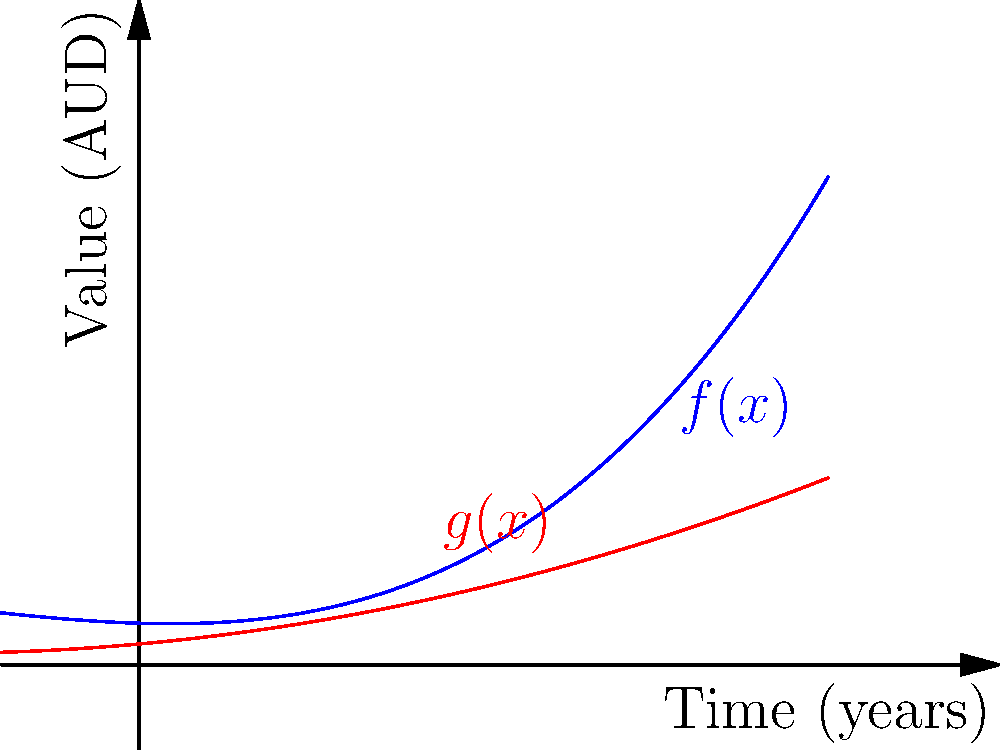As a rare film collector, you're tracking the value of two vintage movie posters over time. The blue curve represents the value of a classic Australian film poster ($f(x)$), while the red curve represents an international blockbuster poster ($g(x)$). Both functions are polynomials, where $x$ represents the number of years from now. At which point in the future will the value of the Australian film poster start growing faster than the international blockbuster poster? To determine when the Australian film poster's value ($f(x)$) starts growing faster than the international blockbuster poster's value ($g(x)$), we need to compare their rates of change. This is done by comparing their derivatives.

1) First, let's find the derivatives of both functions:
   $f(x) = 0.5x^3 + 2x^2 - x + 10$
   $f'(x) = 1.5x^2 + 4x - 1$

   $g(x) = x^2 + 3x + 5$
   $g'(x) = 2x + 3$

2) The Australian poster's value is growing faster when $f'(x) > g'(x)$. Let's set up this inequality:
   $1.5x^2 + 4x - 1 > 2x + 3$

3) Rearrange the inequality:
   $1.5x^2 + 2x - 4 > 0$

4) This is a quadratic inequality. To solve it, we first find the roots of the quadratic equation:
   $1.5x^2 + 2x - 4 = 0$

5) Using the quadratic formula, we get:
   $x = \frac{-2 \pm \sqrt{4 + 24}}{3} = \frac{-2 \pm \sqrt{28}}{3}$

6) Simplifying:
   $x \approx 1.09$ or $x \approx -2.42$

7) Since we're dealing with future time, we're only interested in the positive root. The parabola opens upward (coefficient of $x^2$ is positive), so the inequality is satisfied when $x > 1.09$.

Therefore, the Australian film poster's value will start growing faster than the international blockbuster poster's value approximately 1.09 years from now.
Answer: After approximately 1.09 years 